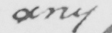Transcribe the text shown in this historical manuscript line. any 